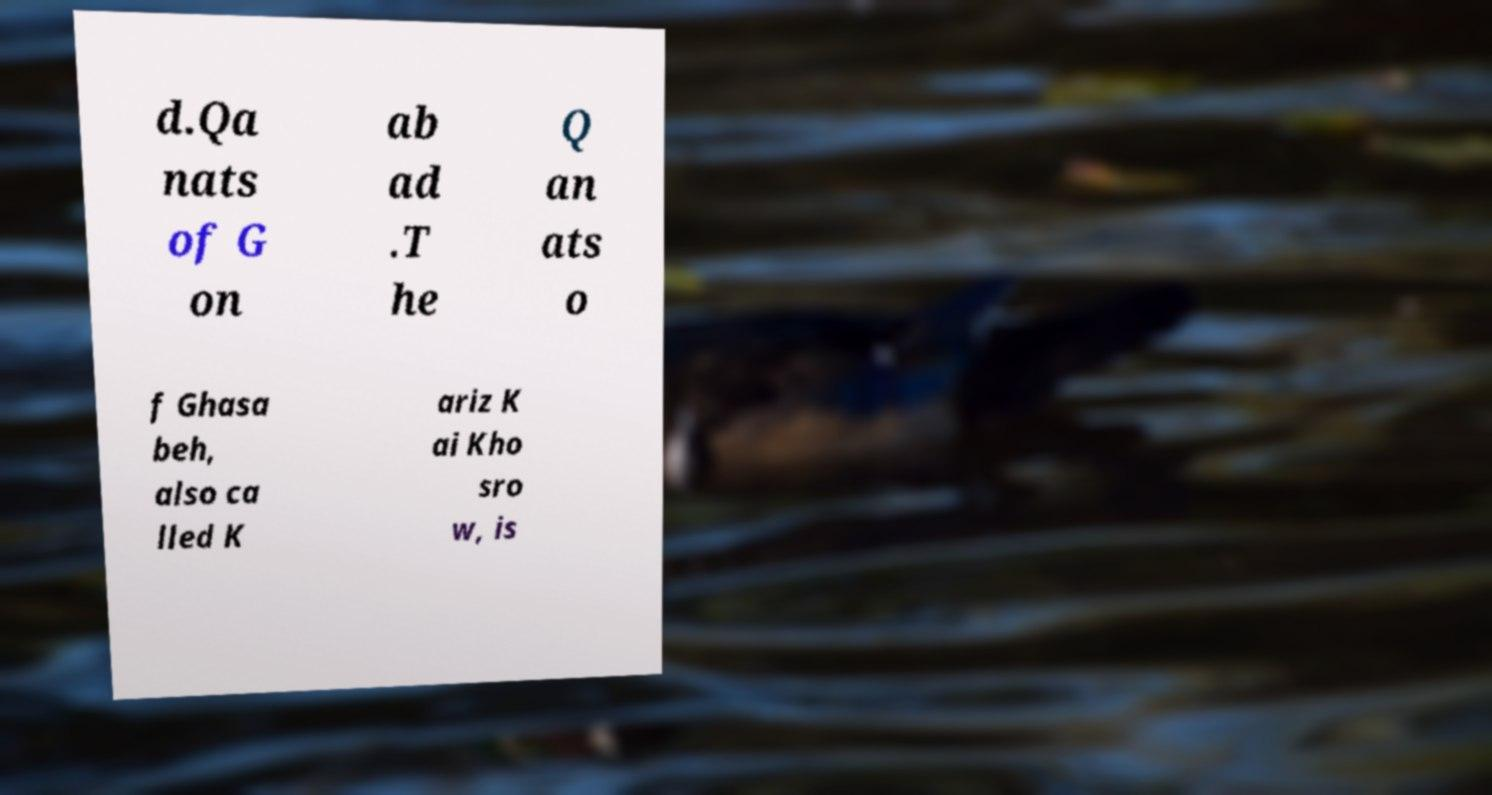I need the written content from this picture converted into text. Can you do that? d.Qa nats of G on ab ad .T he Q an ats o f Ghasa beh, also ca lled K ariz K ai Kho sro w, is 